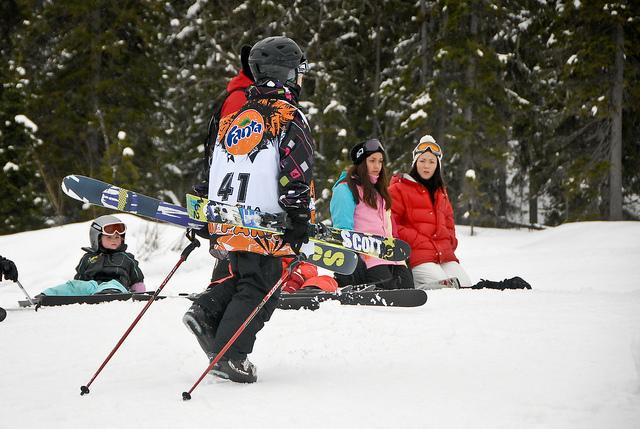What color are the poles dragged around by the young child with his skis?

Choices:
A) black
B) orange
C) white
D) red red 